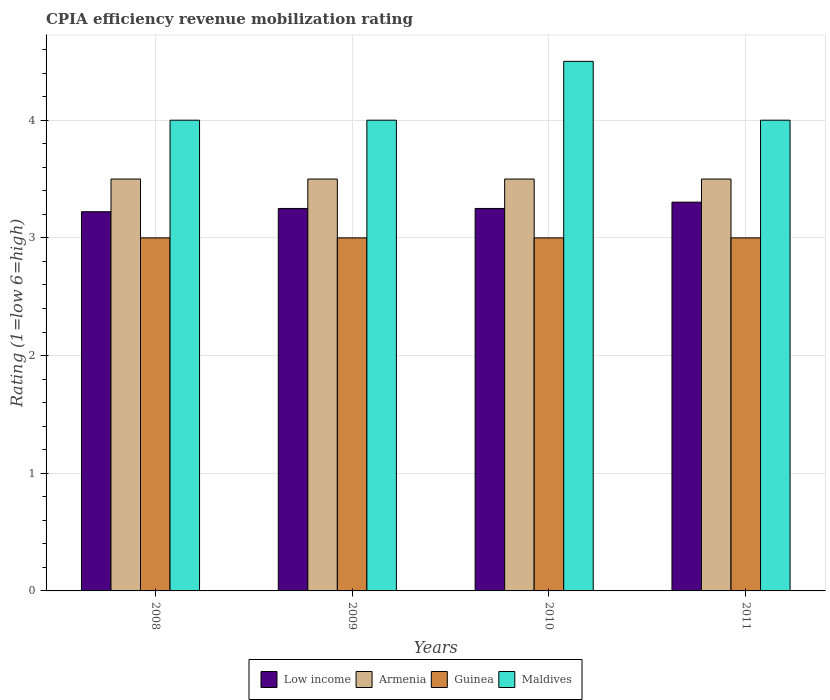Are the number of bars per tick equal to the number of legend labels?
Give a very brief answer. Yes. How many bars are there on the 1st tick from the left?
Give a very brief answer. 4. What is the label of the 3rd group of bars from the left?
Your response must be concise. 2010. In how many cases, is the number of bars for a given year not equal to the number of legend labels?
Ensure brevity in your answer.  0. What is the CPIA rating in Guinea in 2010?
Keep it short and to the point. 3. Across all years, what is the maximum CPIA rating in Guinea?
Give a very brief answer. 3. Across all years, what is the minimum CPIA rating in Armenia?
Keep it short and to the point. 3.5. In which year was the CPIA rating in Armenia maximum?
Your response must be concise. 2008. What is the difference between the CPIA rating in Low income in 2009 and that in 2011?
Make the answer very short. -0.05. What is the difference between the CPIA rating in Low income in 2008 and the CPIA rating in Armenia in 2010?
Make the answer very short. -0.28. In the year 2011, what is the difference between the CPIA rating in Maldives and CPIA rating in Guinea?
Provide a short and direct response. 1. In how many years, is the CPIA rating in Low income greater than 0.2?
Your answer should be very brief. 4. What is the ratio of the CPIA rating in Armenia in 2008 to that in 2011?
Ensure brevity in your answer.  1. What is the difference between the highest and the second highest CPIA rating in Maldives?
Your answer should be very brief. 0.5. What does the 3rd bar from the left in 2009 represents?
Provide a short and direct response. Guinea. What does the 3rd bar from the right in 2009 represents?
Give a very brief answer. Armenia. Is it the case that in every year, the sum of the CPIA rating in Maldives and CPIA rating in Guinea is greater than the CPIA rating in Armenia?
Your response must be concise. Yes. Are all the bars in the graph horizontal?
Your response must be concise. No. Does the graph contain any zero values?
Keep it short and to the point. No. Where does the legend appear in the graph?
Give a very brief answer. Bottom center. How are the legend labels stacked?
Provide a short and direct response. Horizontal. What is the title of the graph?
Make the answer very short. CPIA efficiency revenue mobilization rating. Does "Germany" appear as one of the legend labels in the graph?
Ensure brevity in your answer.  No. What is the label or title of the X-axis?
Offer a terse response. Years. What is the Rating (1=low 6=high) of Low income in 2008?
Provide a short and direct response. 3.22. What is the Rating (1=low 6=high) of Guinea in 2008?
Ensure brevity in your answer.  3. What is the Rating (1=low 6=high) of Low income in 2009?
Offer a very short reply. 3.25. What is the Rating (1=low 6=high) in Guinea in 2009?
Ensure brevity in your answer.  3. What is the Rating (1=low 6=high) of Low income in 2010?
Provide a succinct answer. 3.25. What is the Rating (1=low 6=high) of Guinea in 2010?
Your answer should be very brief. 3. What is the Rating (1=low 6=high) in Low income in 2011?
Your answer should be very brief. 3.3. What is the Rating (1=low 6=high) of Maldives in 2011?
Make the answer very short. 4. Across all years, what is the maximum Rating (1=low 6=high) in Low income?
Give a very brief answer. 3.3. Across all years, what is the maximum Rating (1=low 6=high) in Maldives?
Give a very brief answer. 4.5. Across all years, what is the minimum Rating (1=low 6=high) in Low income?
Make the answer very short. 3.22. Across all years, what is the minimum Rating (1=low 6=high) in Guinea?
Offer a terse response. 3. What is the total Rating (1=low 6=high) in Low income in the graph?
Your answer should be very brief. 13.03. What is the total Rating (1=low 6=high) in Guinea in the graph?
Provide a succinct answer. 12. What is the total Rating (1=low 6=high) of Maldives in the graph?
Provide a succinct answer. 16.5. What is the difference between the Rating (1=low 6=high) in Low income in 2008 and that in 2009?
Keep it short and to the point. -0.03. What is the difference between the Rating (1=low 6=high) of Guinea in 2008 and that in 2009?
Keep it short and to the point. 0. What is the difference between the Rating (1=low 6=high) in Maldives in 2008 and that in 2009?
Offer a terse response. 0. What is the difference between the Rating (1=low 6=high) in Low income in 2008 and that in 2010?
Your response must be concise. -0.03. What is the difference between the Rating (1=low 6=high) in Armenia in 2008 and that in 2010?
Offer a very short reply. 0. What is the difference between the Rating (1=low 6=high) in Guinea in 2008 and that in 2010?
Offer a very short reply. 0. What is the difference between the Rating (1=low 6=high) of Maldives in 2008 and that in 2010?
Keep it short and to the point. -0.5. What is the difference between the Rating (1=low 6=high) of Low income in 2008 and that in 2011?
Ensure brevity in your answer.  -0.08. What is the difference between the Rating (1=low 6=high) of Maldives in 2008 and that in 2011?
Keep it short and to the point. 0. What is the difference between the Rating (1=low 6=high) of Low income in 2009 and that in 2010?
Your answer should be very brief. 0. What is the difference between the Rating (1=low 6=high) in Guinea in 2009 and that in 2010?
Your answer should be very brief. 0. What is the difference between the Rating (1=low 6=high) in Maldives in 2009 and that in 2010?
Give a very brief answer. -0.5. What is the difference between the Rating (1=low 6=high) in Low income in 2009 and that in 2011?
Give a very brief answer. -0.05. What is the difference between the Rating (1=low 6=high) of Armenia in 2009 and that in 2011?
Give a very brief answer. 0. What is the difference between the Rating (1=low 6=high) of Low income in 2010 and that in 2011?
Make the answer very short. -0.05. What is the difference between the Rating (1=low 6=high) in Guinea in 2010 and that in 2011?
Your answer should be compact. 0. What is the difference between the Rating (1=low 6=high) in Low income in 2008 and the Rating (1=low 6=high) in Armenia in 2009?
Give a very brief answer. -0.28. What is the difference between the Rating (1=low 6=high) in Low income in 2008 and the Rating (1=low 6=high) in Guinea in 2009?
Offer a terse response. 0.22. What is the difference between the Rating (1=low 6=high) in Low income in 2008 and the Rating (1=low 6=high) in Maldives in 2009?
Offer a very short reply. -0.78. What is the difference between the Rating (1=low 6=high) of Guinea in 2008 and the Rating (1=low 6=high) of Maldives in 2009?
Your response must be concise. -1. What is the difference between the Rating (1=low 6=high) in Low income in 2008 and the Rating (1=low 6=high) in Armenia in 2010?
Offer a terse response. -0.28. What is the difference between the Rating (1=low 6=high) of Low income in 2008 and the Rating (1=low 6=high) of Guinea in 2010?
Provide a succinct answer. 0.22. What is the difference between the Rating (1=low 6=high) in Low income in 2008 and the Rating (1=low 6=high) in Maldives in 2010?
Make the answer very short. -1.28. What is the difference between the Rating (1=low 6=high) of Armenia in 2008 and the Rating (1=low 6=high) of Maldives in 2010?
Your answer should be very brief. -1. What is the difference between the Rating (1=low 6=high) of Low income in 2008 and the Rating (1=low 6=high) of Armenia in 2011?
Make the answer very short. -0.28. What is the difference between the Rating (1=low 6=high) of Low income in 2008 and the Rating (1=low 6=high) of Guinea in 2011?
Your answer should be compact. 0.22. What is the difference between the Rating (1=low 6=high) in Low income in 2008 and the Rating (1=low 6=high) in Maldives in 2011?
Your response must be concise. -0.78. What is the difference between the Rating (1=low 6=high) of Armenia in 2008 and the Rating (1=low 6=high) of Maldives in 2011?
Your answer should be very brief. -0.5. What is the difference between the Rating (1=low 6=high) in Guinea in 2008 and the Rating (1=low 6=high) in Maldives in 2011?
Provide a succinct answer. -1. What is the difference between the Rating (1=low 6=high) of Low income in 2009 and the Rating (1=low 6=high) of Maldives in 2010?
Offer a terse response. -1.25. What is the difference between the Rating (1=low 6=high) in Armenia in 2009 and the Rating (1=low 6=high) in Guinea in 2010?
Your response must be concise. 0.5. What is the difference between the Rating (1=low 6=high) of Low income in 2009 and the Rating (1=low 6=high) of Guinea in 2011?
Make the answer very short. 0.25. What is the difference between the Rating (1=low 6=high) of Low income in 2009 and the Rating (1=low 6=high) of Maldives in 2011?
Provide a short and direct response. -0.75. What is the difference between the Rating (1=low 6=high) of Armenia in 2009 and the Rating (1=low 6=high) of Maldives in 2011?
Offer a terse response. -0.5. What is the difference between the Rating (1=low 6=high) in Guinea in 2009 and the Rating (1=low 6=high) in Maldives in 2011?
Make the answer very short. -1. What is the difference between the Rating (1=low 6=high) in Low income in 2010 and the Rating (1=low 6=high) in Guinea in 2011?
Offer a terse response. 0.25. What is the difference between the Rating (1=low 6=high) of Low income in 2010 and the Rating (1=low 6=high) of Maldives in 2011?
Offer a terse response. -0.75. What is the difference between the Rating (1=low 6=high) in Armenia in 2010 and the Rating (1=low 6=high) in Maldives in 2011?
Offer a very short reply. -0.5. What is the difference between the Rating (1=low 6=high) of Guinea in 2010 and the Rating (1=low 6=high) of Maldives in 2011?
Offer a very short reply. -1. What is the average Rating (1=low 6=high) in Low income per year?
Your answer should be very brief. 3.26. What is the average Rating (1=low 6=high) in Guinea per year?
Keep it short and to the point. 3. What is the average Rating (1=low 6=high) of Maldives per year?
Make the answer very short. 4.12. In the year 2008, what is the difference between the Rating (1=low 6=high) of Low income and Rating (1=low 6=high) of Armenia?
Your response must be concise. -0.28. In the year 2008, what is the difference between the Rating (1=low 6=high) in Low income and Rating (1=low 6=high) in Guinea?
Give a very brief answer. 0.22. In the year 2008, what is the difference between the Rating (1=low 6=high) of Low income and Rating (1=low 6=high) of Maldives?
Make the answer very short. -0.78. In the year 2008, what is the difference between the Rating (1=low 6=high) in Armenia and Rating (1=low 6=high) in Maldives?
Provide a succinct answer. -0.5. In the year 2008, what is the difference between the Rating (1=low 6=high) of Guinea and Rating (1=low 6=high) of Maldives?
Ensure brevity in your answer.  -1. In the year 2009, what is the difference between the Rating (1=low 6=high) of Low income and Rating (1=low 6=high) of Armenia?
Give a very brief answer. -0.25. In the year 2009, what is the difference between the Rating (1=low 6=high) of Low income and Rating (1=low 6=high) of Maldives?
Ensure brevity in your answer.  -0.75. In the year 2009, what is the difference between the Rating (1=low 6=high) in Armenia and Rating (1=low 6=high) in Maldives?
Ensure brevity in your answer.  -0.5. In the year 2009, what is the difference between the Rating (1=low 6=high) of Guinea and Rating (1=low 6=high) of Maldives?
Your response must be concise. -1. In the year 2010, what is the difference between the Rating (1=low 6=high) in Low income and Rating (1=low 6=high) in Armenia?
Make the answer very short. -0.25. In the year 2010, what is the difference between the Rating (1=low 6=high) in Low income and Rating (1=low 6=high) in Guinea?
Your response must be concise. 0.25. In the year 2010, what is the difference between the Rating (1=low 6=high) in Low income and Rating (1=low 6=high) in Maldives?
Offer a very short reply. -1.25. In the year 2010, what is the difference between the Rating (1=low 6=high) of Armenia and Rating (1=low 6=high) of Guinea?
Your answer should be compact. 0.5. In the year 2011, what is the difference between the Rating (1=low 6=high) of Low income and Rating (1=low 6=high) of Armenia?
Give a very brief answer. -0.2. In the year 2011, what is the difference between the Rating (1=low 6=high) of Low income and Rating (1=low 6=high) of Guinea?
Provide a short and direct response. 0.3. In the year 2011, what is the difference between the Rating (1=low 6=high) of Low income and Rating (1=low 6=high) of Maldives?
Your response must be concise. -0.7. What is the ratio of the Rating (1=low 6=high) in Low income in 2008 to that in 2009?
Offer a terse response. 0.99. What is the ratio of the Rating (1=low 6=high) of Guinea in 2008 to that in 2009?
Offer a terse response. 1. What is the ratio of the Rating (1=low 6=high) of Maldives in 2008 to that in 2009?
Ensure brevity in your answer.  1. What is the ratio of the Rating (1=low 6=high) of Maldives in 2008 to that in 2010?
Provide a succinct answer. 0.89. What is the ratio of the Rating (1=low 6=high) of Low income in 2008 to that in 2011?
Provide a succinct answer. 0.98. What is the ratio of the Rating (1=low 6=high) of Armenia in 2008 to that in 2011?
Give a very brief answer. 1. What is the ratio of the Rating (1=low 6=high) in Maldives in 2008 to that in 2011?
Offer a very short reply. 1. What is the ratio of the Rating (1=low 6=high) of Low income in 2009 to that in 2010?
Provide a succinct answer. 1. What is the ratio of the Rating (1=low 6=high) in Guinea in 2009 to that in 2010?
Provide a short and direct response. 1. What is the ratio of the Rating (1=low 6=high) of Low income in 2009 to that in 2011?
Your response must be concise. 0.98. What is the ratio of the Rating (1=low 6=high) of Armenia in 2009 to that in 2011?
Make the answer very short. 1. What is the ratio of the Rating (1=low 6=high) of Maldives in 2009 to that in 2011?
Give a very brief answer. 1. What is the ratio of the Rating (1=low 6=high) of Low income in 2010 to that in 2011?
Keep it short and to the point. 0.98. What is the ratio of the Rating (1=low 6=high) in Armenia in 2010 to that in 2011?
Make the answer very short. 1. What is the ratio of the Rating (1=low 6=high) of Guinea in 2010 to that in 2011?
Keep it short and to the point. 1. What is the difference between the highest and the second highest Rating (1=low 6=high) of Low income?
Provide a short and direct response. 0.05. What is the difference between the highest and the second highest Rating (1=low 6=high) in Guinea?
Your response must be concise. 0. What is the difference between the highest and the second highest Rating (1=low 6=high) in Maldives?
Give a very brief answer. 0.5. What is the difference between the highest and the lowest Rating (1=low 6=high) in Low income?
Keep it short and to the point. 0.08. What is the difference between the highest and the lowest Rating (1=low 6=high) in Maldives?
Keep it short and to the point. 0.5. 